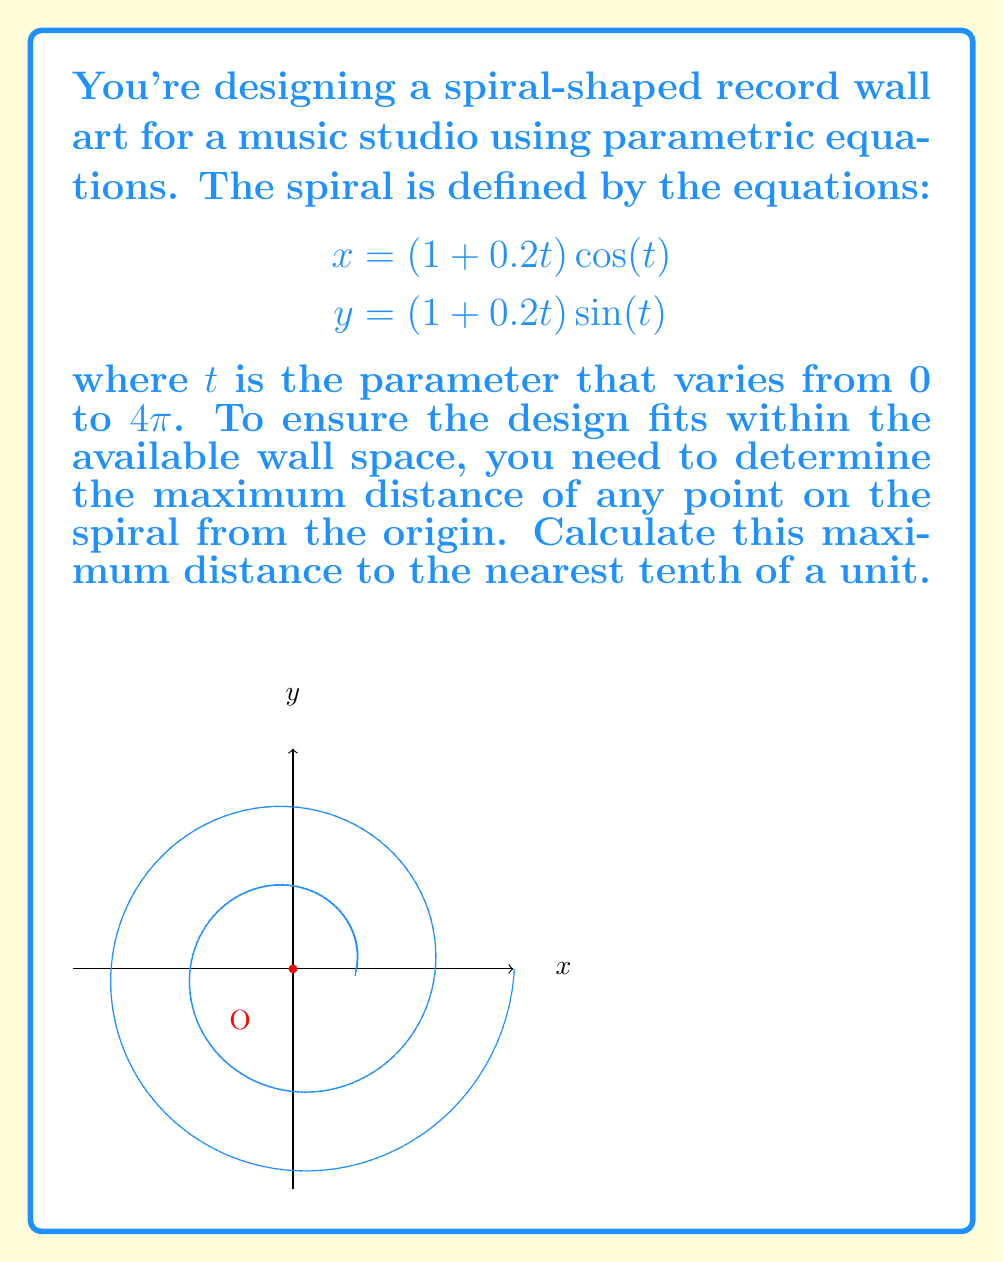Help me with this question. Let's approach this step-by-step:

1) The distance of any point $(x, y)$ from the origin is given by $\sqrt{x^2 + y^2}$.

2) Substituting the parametric equations:
   $$\sqrt{x^2 + y^2} = \sqrt{((1 + 0.2t) \cos(t))^2 + ((1 + 0.2t) \sin(t))^2}$$

3) Simplify using the identity $\cos^2(t) + \sin^2(t) = 1$:
   $$\sqrt{x^2 + y^2} = \sqrt{(1 + 0.2t)^2 (\cos^2(t) + \sin^2(t))} = 1 + 0.2t$$

4) The maximum distance will occur at the largest value of $t$, which is $4\pi$.

5) Calculate the maximum distance:
   $$1 + 0.2(4\pi) = 1 + 0.8\pi \approx 3.51327$$

6) Rounding to the nearest tenth:
   $$3.51327 \approx 3.5$$

Therefore, the maximum distance from the origin to any point on the spiral is approximately 3.5 units.
Answer: 3.5 units 